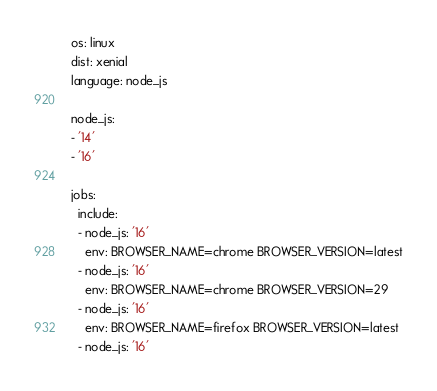<code> <loc_0><loc_0><loc_500><loc_500><_YAML_>os: linux
dist: xenial
language: node_js

node_js:
- '14'
- '16'

jobs:
  include:
  - node_js: '16'
    env: BROWSER_NAME=chrome BROWSER_VERSION=latest
  - node_js: '16'
    env: BROWSER_NAME=chrome BROWSER_VERSION=29
  - node_js: '16'
    env: BROWSER_NAME=firefox BROWSER_VERSION=latest
  - node_js: '16'</code> 